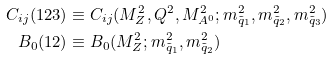Convert formula to latex. <formula><loc_0><loc_0><loc_500><loc_500>C _ { i j } ( 1 2 3 ) & \equiv C _ { i j } ( M _ { Z } ^ { 2 } , Q ^ { 2 } , M _ { A ^ { 0 } } ^ { 2 } ; m _ { \tilde { q } _ { 1 } } ^ { 2 } , m _ { \tilde { q } _ { 2 } } ^ { 2 } , m _ { \tilde { q } _ { 3 } } ^ { 2 } ) \\ B _ { 0 } ( 1 2 ) & \equiv B _ { 0 } ( M _ { Z } ^ { 2 } ; m _ { \tilde { q } _ { 1 } } ^ { 2 } , m _ { \tilde { q } _ { 2 } } ^ { 2 } )</formula> 